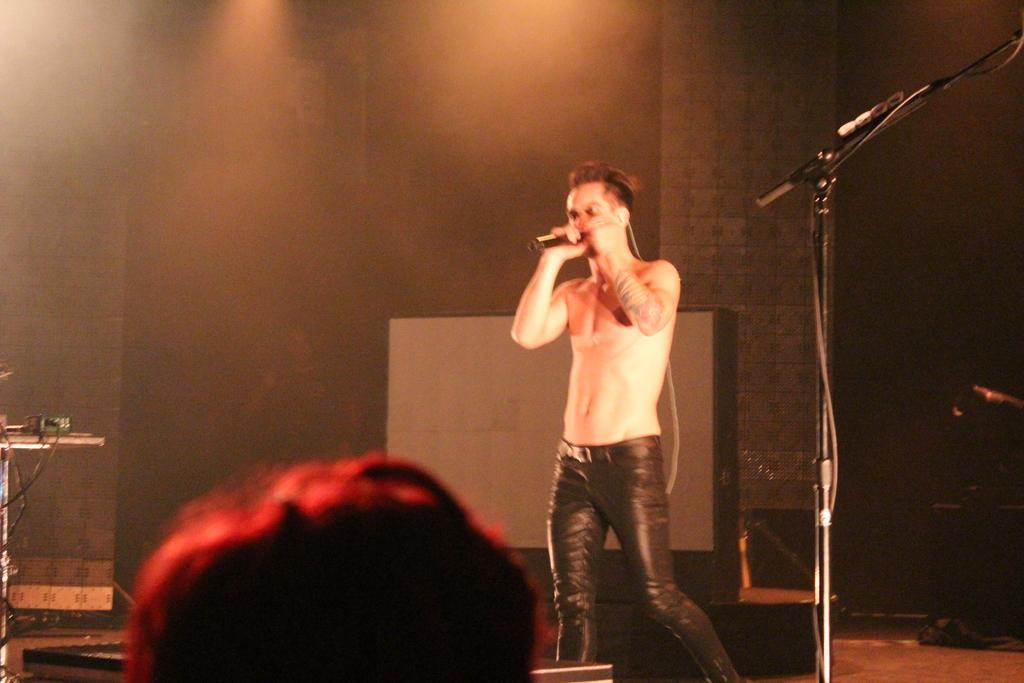In one or two sentences, can you explain what this image depicts? In the image there is a man singing on mic, on the right side there is a mic stand. In the background its bit dark,there is light focused coming from ceiling. 